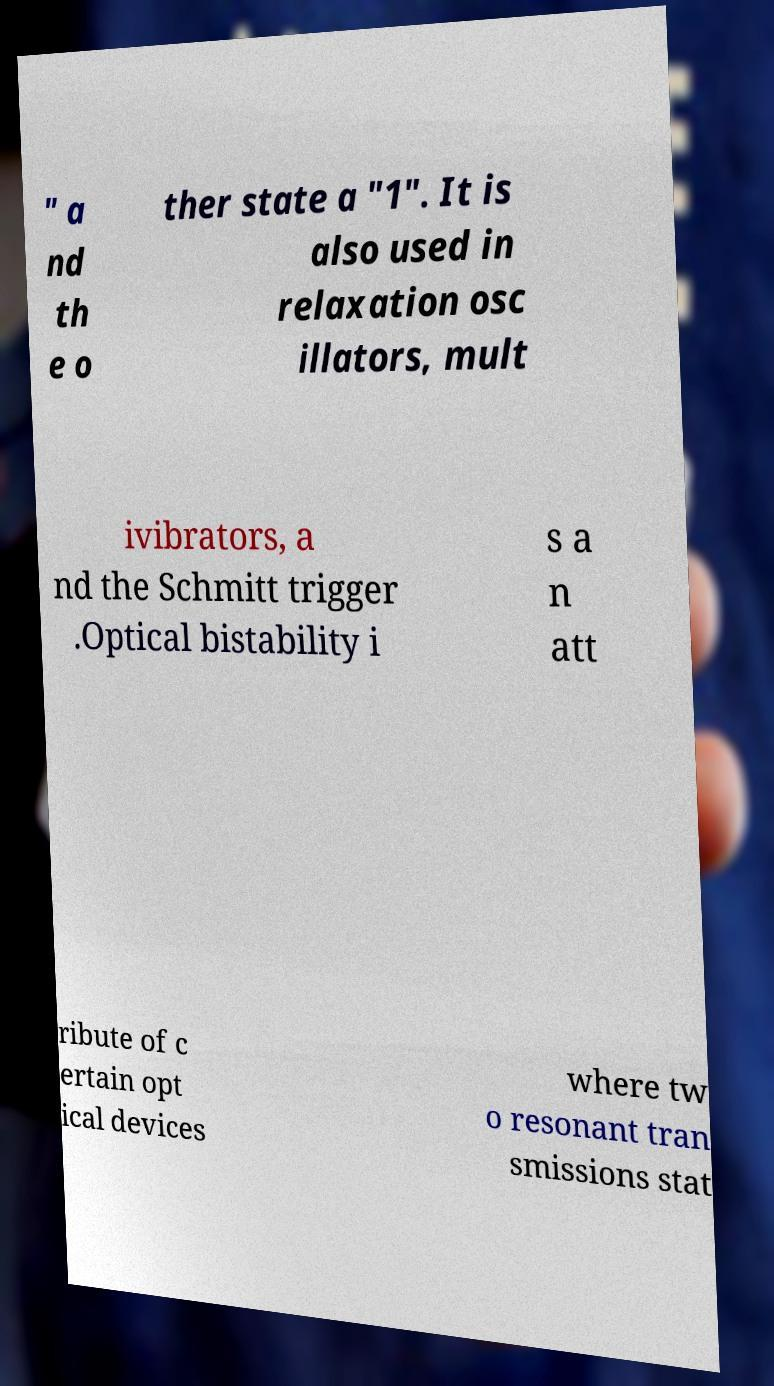Could you assist in decoding the text presented in this image and type it out clearly? " a nd th e o ther state a "1". It is also used in relaxation osc illators, mult ivibrators, a nd the Schmitt trigger .Optical bistability i s a n att ribute of c ertain opt ical devices where tw o resonant tran smissions stat 